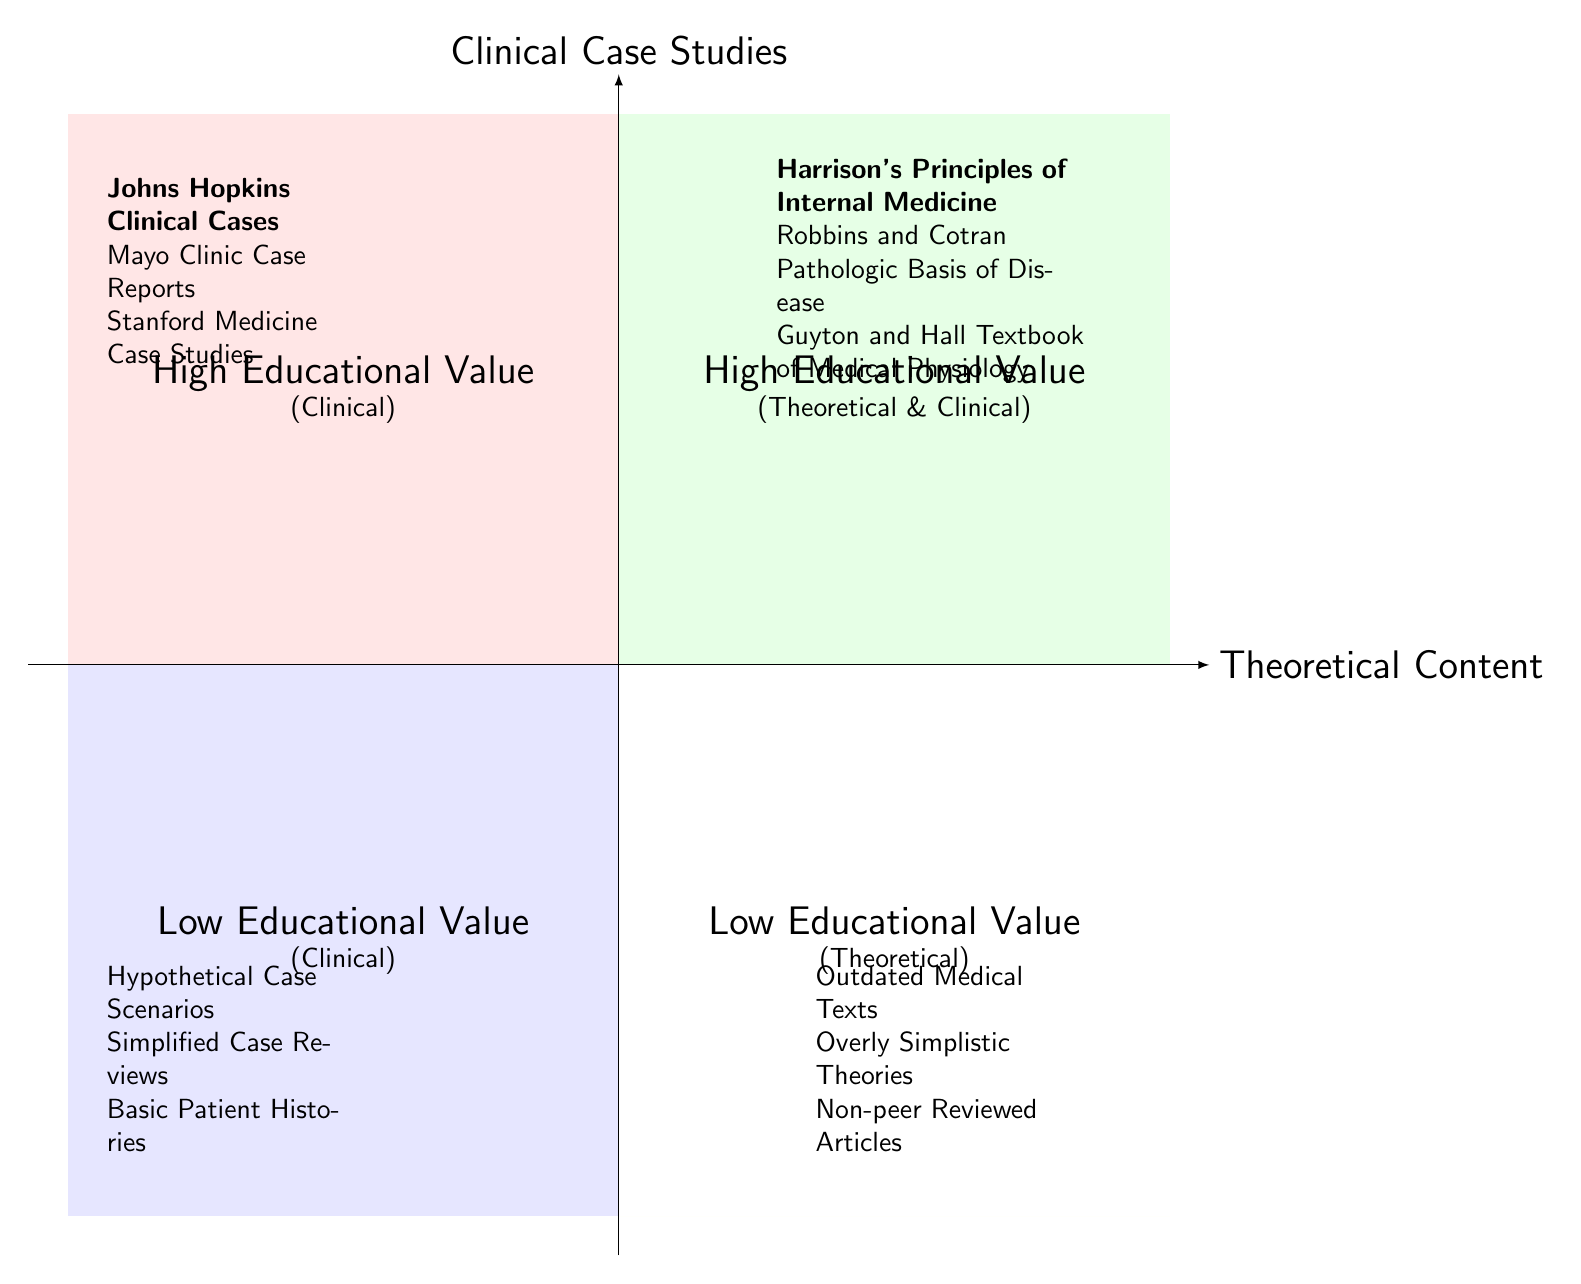What are three examples of high educational value clinical case studies? The diagram lists the high educational value clinical case studies in the upper left quadrant. These include "Johns Hopkins Clinical Cases," "Mayo Clinic Case Reports," and "Stanford Medicine Case Studies."
Answer: Johns Hopkins Clinical Cases, Mayo Clinic Case Reports, Stanford Medicine Case Studies How many low educational value theoretical content items are listed? The lower right quadrant includes three items of low educational value theoretical content: "Outdated Medical Texts," "Overly Simplistic Theories," and "Non-peer Reviewed Articles." Counting these yields a total of three.
Answer: 3 Which quadrant contains the "Robbins and Cotran Pathologic Basis of Disease"? "Robbins and Cotran Pathologic Basis of Disease" is categorized in the high educational value theoretical content located in the upper right quadrant.
Answer: High Educational Value (Theoretical) What is the educational value of "Hypothetical Case Scenarios"? According to the diagram, "Hypothetical Case Scenarios" is positioned in the lower left quadrant, indicating it has low educational value as a clinical case study.
Answer: Low Educational Value Which theoretical content has the highest educational value listed? The highest educational value theoretical content listed in the upper right quadrant is "Harrison's Principles of Internal Medicine," as indicated by its placement and prominence in that section of the diagram.
Answer: Harrison's Principles of Internal Medicine What relationship exists between "Standard Medicine Case Studies" and educational value? "Stanford Medicine Case Studies" is placed in the upper left quadrant, which is designated for high educational value clinical case studies. This indicates that it is perceived as having a significant educational benefit in the context of clinical case studies.
Answer: High Educational Value Which type of content is more prevalent in the diagram, clinical case studies or theoretical content? By examining the quadrants, both types have two categories each (high and low educational value). However, the number of examples provided in clinical case studies and theoretical content is equal, with three in high educational value and three in low educational value for each type, indicating no prevalence.
Answer: Neither is more prevalent Where is "Overly Simplistic Theories" situated in the diagram? "Overly Simplistic Theories" is located in the lower right quadrant, which represents low educational value theoretical content. This categorization denotes it as a theoretical content with a lower impact on education.
Answer: Low Educational Value (Theoretical) 